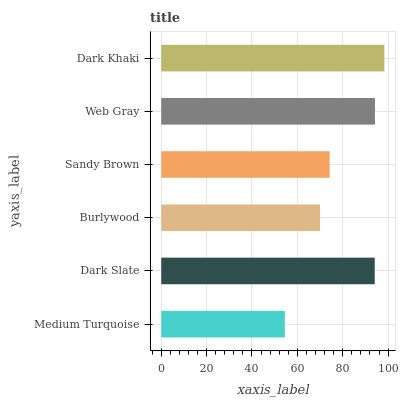Is Medium Turquoise the minimum?
Answer yes or no. Yes. Is Dark Khaki the maximum?
Answer yes or no. Yes. Is Dark Slate the minimum?
Answer yes or no. No. Is Dark Slate the maximum?
Answer yes or no. No. Is Dark Slate greater than Medium Turquoise?
Answer yes or no. Yes. Is Medium Turquoise less than Dark Slate?
Answer yes or no. Yes. Is Medium Turquoise greater than Dark Slate?
Answer yes or no. No. Is Dark Slate less than Medium Turquoise?
Answer yes or no. No. Is Dark Slate the high median?
Answer yes or no. Yes. Is Sandy Brown the low median?
Answer yes or no. Yes. Is Dark Khaki the high median?
Answer yes or no. No. Is Burlywood the low median?
Answer yes or no. No. 